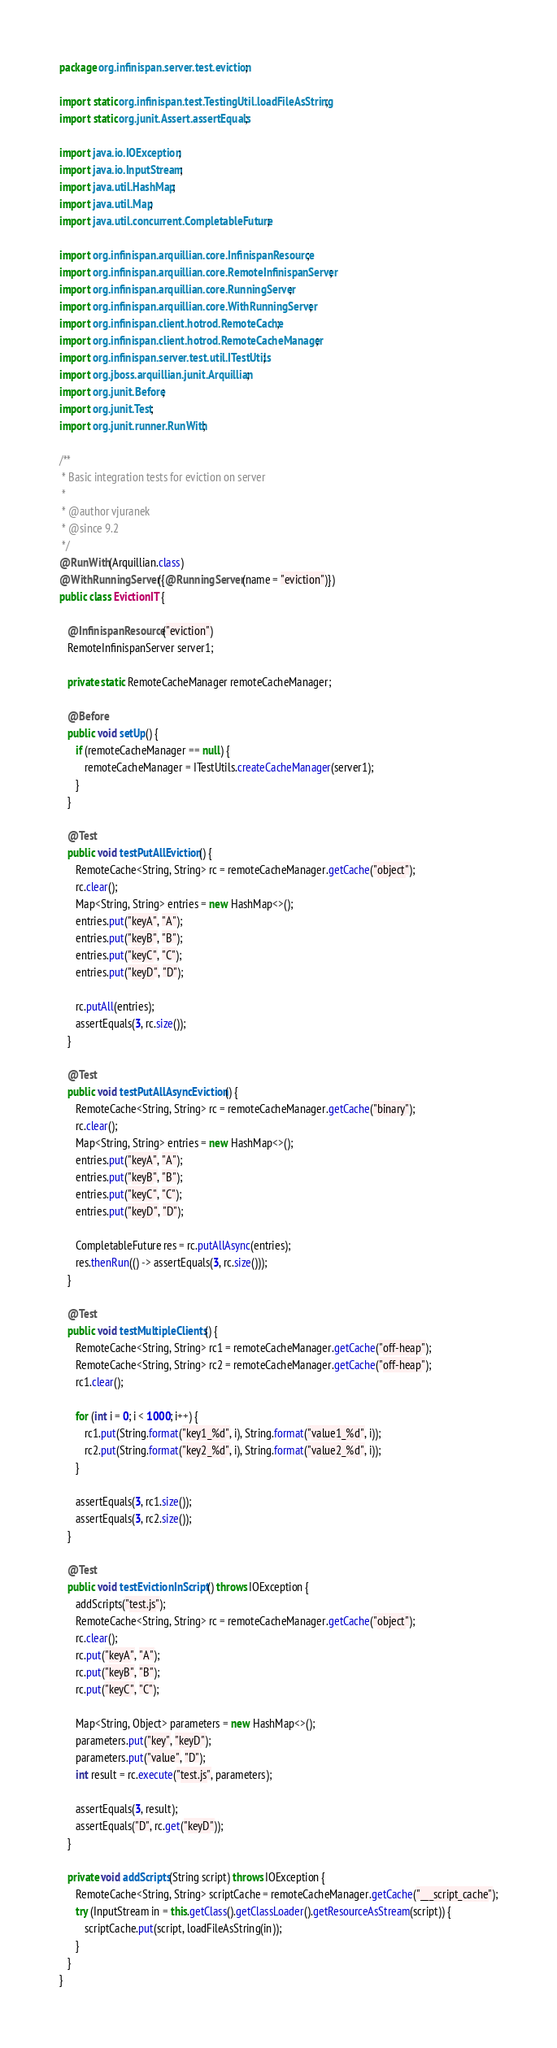<code> <loc_0><loc_0><loc_500><loc_500><_Java_>package org.infinispan.server.test.eviction;

import static org.infinispan.test.TestingUtil.loadFileAsString;
import static org.junit.Assert.assertEquals;

import java.io.IOException;
import java.io.InputStream;
import java.util.HashMap;
import java.util.Map;
import java.util.concurrent.CompletableFuture;

import org.infinispan.arquillian.core.InfinispanResource;
import org.infinispan.arquillian.core.RemoteInfinispanServer;
import org.infinispan.arquillian.core.RunningServer;
import org.infinispan.arquillian.core.WithRunningServer;
import org.infinispan.client.hotrod.RemoteCache;
import org.infinispan.client.hotrod.RemoteCacheManager;
import org.infinispan.server.test.util.ITestUtils;
import org.jboss.arquillian.junit.Arquillian;
import org.junit.Before;
import org.junit.Test;
import org.junit.runner.RunWith;

/**
 * Basic integration tests for eviction on server
 *
 * @author vjuranek
 * @since 9.2
 */
@RunWith(Arquillian.class)
@WithRunningServer({@RunningServer(name = "eviction")})
public class EvictionIT {

   @InfinispanResource("eviction")
   RemoteInfinispanServer server1;

   private static RemoteCacheManager remoteCacheManager;

   @Before
   public void setUp() {
      if (remoteCacheManager == null) {
         remoteCacheManager = ITestUtils.createCacheManager(server1);
      }
   }

   @Test
   public void testPutAllEviction() {
      RemoteCache<String, String> rc = remoteCacheManager.getCache("object");
      rc.clear();
      Map<String, String> entries = new HashMap<>();
      entries.put("keyA", "A");
      entries.put("keyB", "B");
      entries.put("keyC", "C");
      entries.put("keyD", "D");

      rc.putAll(entries);
      assertEquals(3, rc.size());
   }

   @Test
   public void testPutAllAsyncEviction() {
      RemoteCache<String, String> rc = remoteCacheManager.getCache("binary");
      rc.clear();
      Map<String, String> entries = new HashMap<>();
      entries.put("keyA", "A");
      entries.put("keyB", "B");
      entries.put("keyC", "C");
      entries.put("keyD", "D");

      CompletableFuture res = rc.putAllAsync(entries);
      res.thenRun(() -> assertEquals(3, rc.size()));
   }

   @Test
   public void testMultipleClients() {
      RemoteCache<String, String> rc1 = remoteCacheManager.getCache("off-heap");
      RemoteCache<String, String> rc2 = remoteCacheManager.getCache("off-heap");
      rc1.clear();

      for (int i = 0; i < 1000; i++) {
         rc1.put(String.format("key1_%d", i), String.format("value1_%d", i));
         rc2.put(String.format("key2_%d", i), String.format("value2_%d", i));
      }

      assertEquals(3, rc1.size());
      assertEquals(3, rc2.size());
   }

   @Test
   public void testEvictionInScript() throws IOException {
      addScripts("test.js");
      RemoteCache<String, String> rc = remoteCacheManager.getCache("object");
      rc.clear();
      rc.put("keyA", "A");
      rc.put("keyB", "B");
      rc.put("keyC", "C");

      Map<String, Object> parameters = new HashMap<>();
      parameters.put("key", "keyD");
      parameters.put("value", "D");
      int result = rc.execute("test.js", parameters);

      assertEquals(3, result);
      assertEquals("D", rc.get("keyD"));
   }

   private void addScripts(String script) throws IOException {
      RemoteCache<String, String> scriptCache = remoteCacheManager.getCache("___script_cache");
      try (InputStream in = this.getClass().getClassLoader().getResourceAsStream(script)) {
         scriptCache.put(script, loadFileAsString(in));
      }
   }
}
</code> 